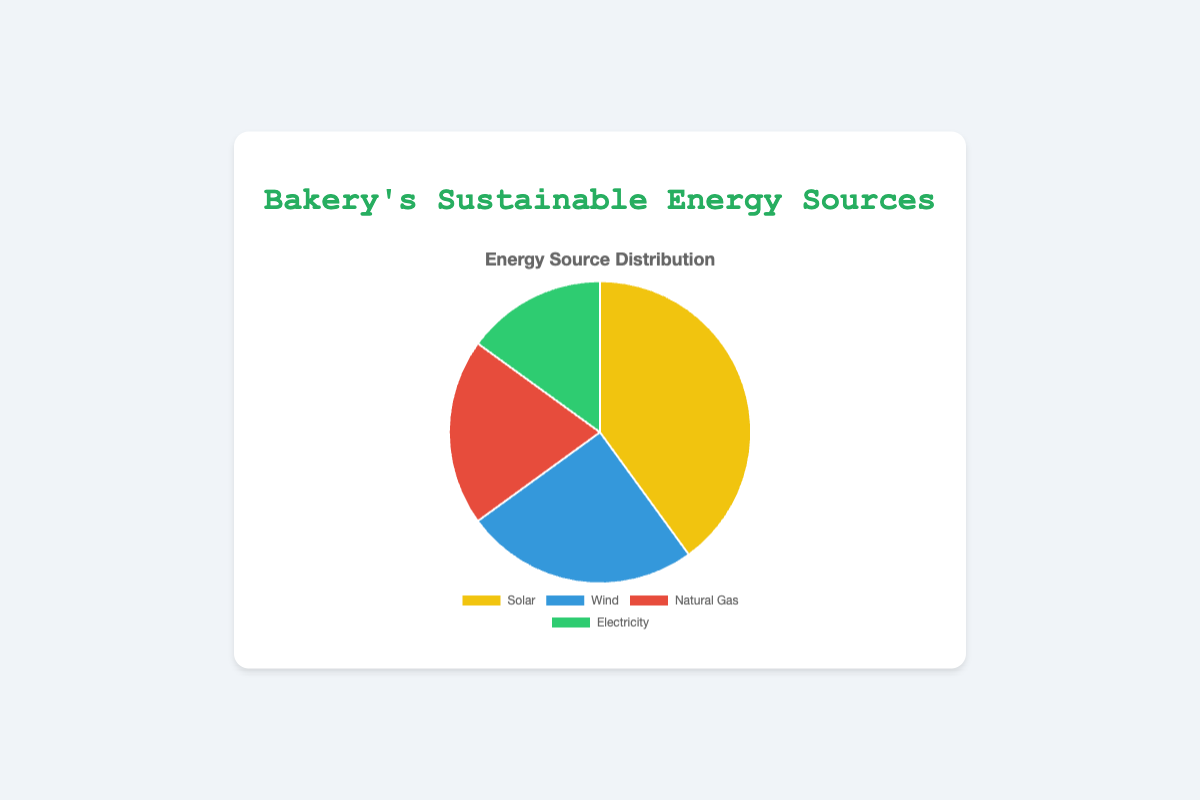What percentage of the bakery's energy comes from renewable sources? Renewable sources include Solar and Wind. Summing their percentages, 40% (Solar) + 25% (Wind) gives a total of 65%.
Answer: 65% Which energy source contributes the most to the bakery's energy usage? By comparing the percentages, the highest is Solar at 40%.
Answer: Solar What is the difference in percentage between Wind and Natural Gas? Wind is 25% and Natural Gas is 20%, so the difference is 25% - 20% = 5%.
Answer: 5% How much more does Solar contribute compared to Electricity? Solar is at 40% and Electricity is at 15%. The difference is 40% - 15% = 25%.
Answer: 25% If the bakery increased its Wind energy usage by 10%, what would be the new percentage for Wind? The current Wind usage is 25%. Adding 10%, the new percentage is 25% + 10% = 35%.
Answer: 35% Which two energy sources, combined, equal the percentage of Solar energy? Adding the percentages of Natural Gas (20%) and Electricity (15%) gives 20% + 15% = 35%, which is not equal to Solar. Adding Wind (25%) to Electricity (15%) gives 25% + 15% = 40%, which equals Solar.
Answer: Wind and Electricity What is the average percentage amount for all energy sources? Summing the percentages: 40% (Solar) + 25% (Wind) + 20% (Natural Gas) + 15% (Electricity) = 100%. Dividing by the number of sources, 100% / 4 = 25%.
Answer: 25% What is the sum of the percentages for non-renewable sources? Non-renewable sources include Natural Gas and Electricity, summing these gives 20% + 15% = 35%.
Answer: 35% If the bakery decided to increase their Natural Gas usage by 5%, what new total percentage would this energy source represent? Current Natural Gas usage is 20%. Increasing by 5% gives 20% + 5% = 25%.
Answer: 25% In terms of visual attributes, which energy source is represented by the color green? Green is used for Electricity in the chart.
Answer: Electricity If Solar and Wind energy sources were each reduced by 10%, what would be the new combined percentage for these sources? Current Solar is 40%, reducing by 10% gives 30%. Current Wind is 25%, reducing by 10% gives 15%. Summing these, 30% + 15% = 45%.
Answer: 45% 